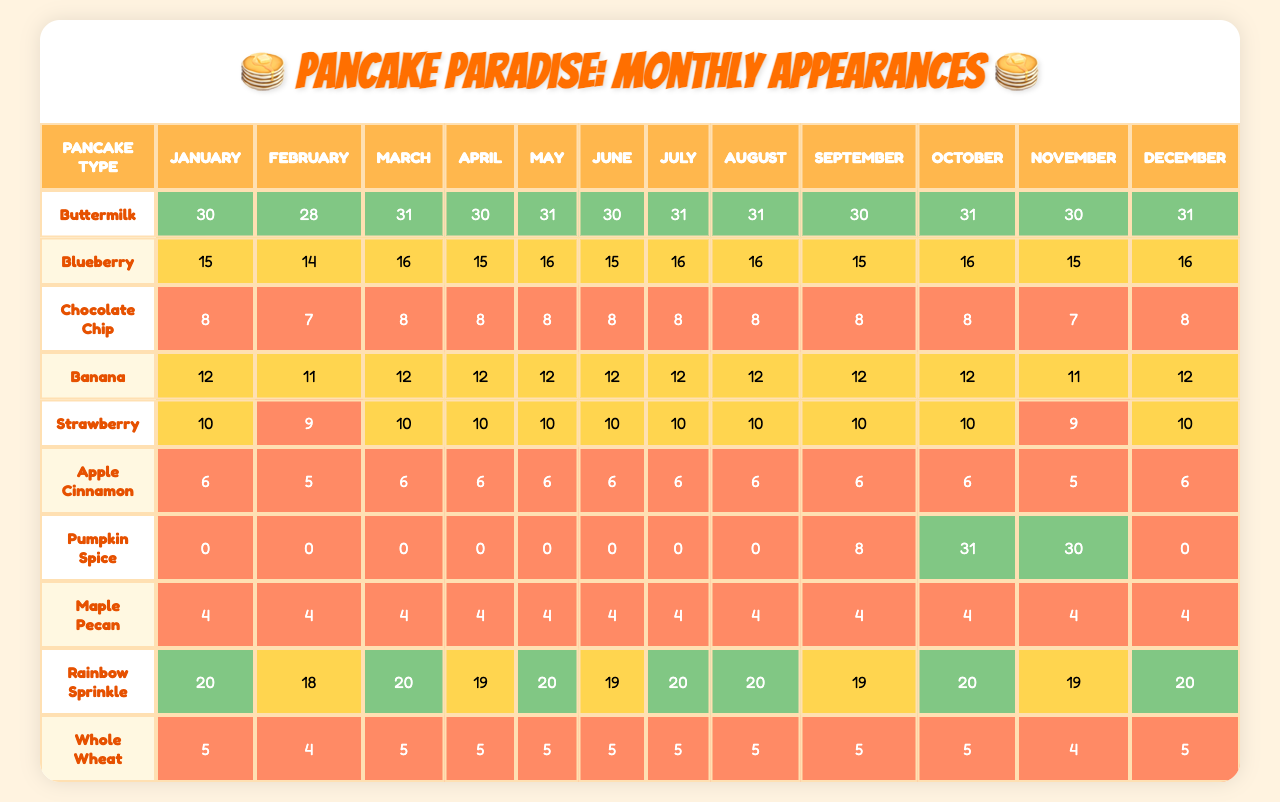What pancake type had the highest appearance in July? Looking at the appearances in July, Buttermilk pancakes appeared 31 times, which is the highest value compared to other types.
Answer: Buttermilk What is the total number of appearances for Blueberry pancakes over the entire year? To find the total for Blueberry pancakes, we add up the monthly appearances: 15 + 14 + 16 + 15 + 16 + 15 + 16 + 16 + 15 + 16 + 15 + 16 = 188
Answer: 188 Did Rainbow Sprinkle pancakes appear in every month? Checking the appearances for Rainbow Sprinkle pancakes, there are values in all months, showing that they did appear each month.
Answer: Yes What was the average appearance of Chocolate Chip pancakes throughout the year? For Chocolate Chip pancakes, we sum the appearances: 8 + 7 + 8 + 8 + 8 + 8 + 8 + 8 + 8 + 8 + 7 + 8 = 96. With 12 months, we divide 96 by 12 to get the average: 96 / 12 = 8.
Answer: 8 Which month had the lowest appearance of Apple Cinnamon pancakes? By examining the monthly appearances for Apple Cinnamon, February had the lowest with 5 appearances.
Answer: February How many more times did Maple Pecan pancakes appear in April compared to October? In April, Maple Pecan pancakes appeared 4 times, and in October, they appeared only 4 times. The difference is 4 - 4 = 0.
Answer: 0 Which pancake type had the highest total for the year, and what is that total? To find this, we compute totals for each pancake type. For all pancake types, the maximum occurs with Buttermilk at 30 + 28 + 31 + 30 + 31 + 30 + 31 + 31 + 30 + 31 + 30 + 31 which gives a total of 364.
Answer: 364 Which pancake type had the largest variation in monthly appearances? Looking at the differences between the highest and lowest monthly appearances for each type shows that Pumpkin Spice appeared 31 times in October and 0 in other months, a variation of 31.
Answer: Pumpkin Spice What is the total appearance of Banana pancakes in the second half of the year? The second half months are July through December: 12 + 12 + 12 + 10 + 12 + 12 = 72 for Banana pancakes.
Answer: 72 Are there more months where Whole Wheat pancakes appeared 5 times than months where Buttermilk pancakes appeared 30 times? Whole Wheat pancakes appeared 5 times in January, March, May, July, September, and November (6 months total), while Buttermilk appeared 30 in April and June (2 months). So, Yes, it has more months.
Answer: Yes 